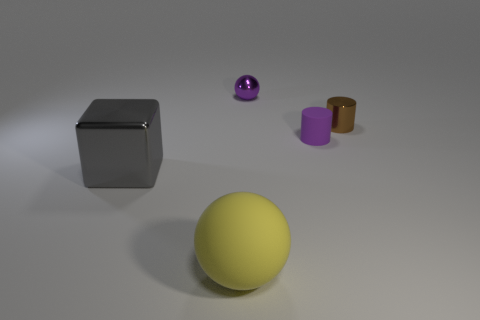Do the metallic ball and the small rubber object have the same color?
Make the answer very short. Yes. The object that is the same color as the rubber cylinder is what size?
Your response must be concise. Small. What is the material of the object right of the tiny cylinder left of the small brown object?
Keep it short and to the point. Metal. There is a metallic sphere; are there any tiny purple matte cylinders on the right side of it?
Provide a succinct answer. Yes. Is the number of tiny spheres on the right side of the small rubber thing greater than the number of small brown balls?
Provide a short and direct response. No. Are there any other big metallic things that have the same color as the big metallic object?
Offer a terse response. No. What color is the rubber object that is the same size as the cube?
Your answer should be compact. Yellow. Is there a thing left of the sphere behind the large yellow matte ball?
Offer a very short reply. Yes. There is a small cylinder that is behind the tiny rubber cylinder; what material is it?
Make the answer very short. Metal. Do the purple object that is to the right of the small purple metal ball and the ball that is behind the tiny matte object have the same material?
Provide a succinct answer. No. 